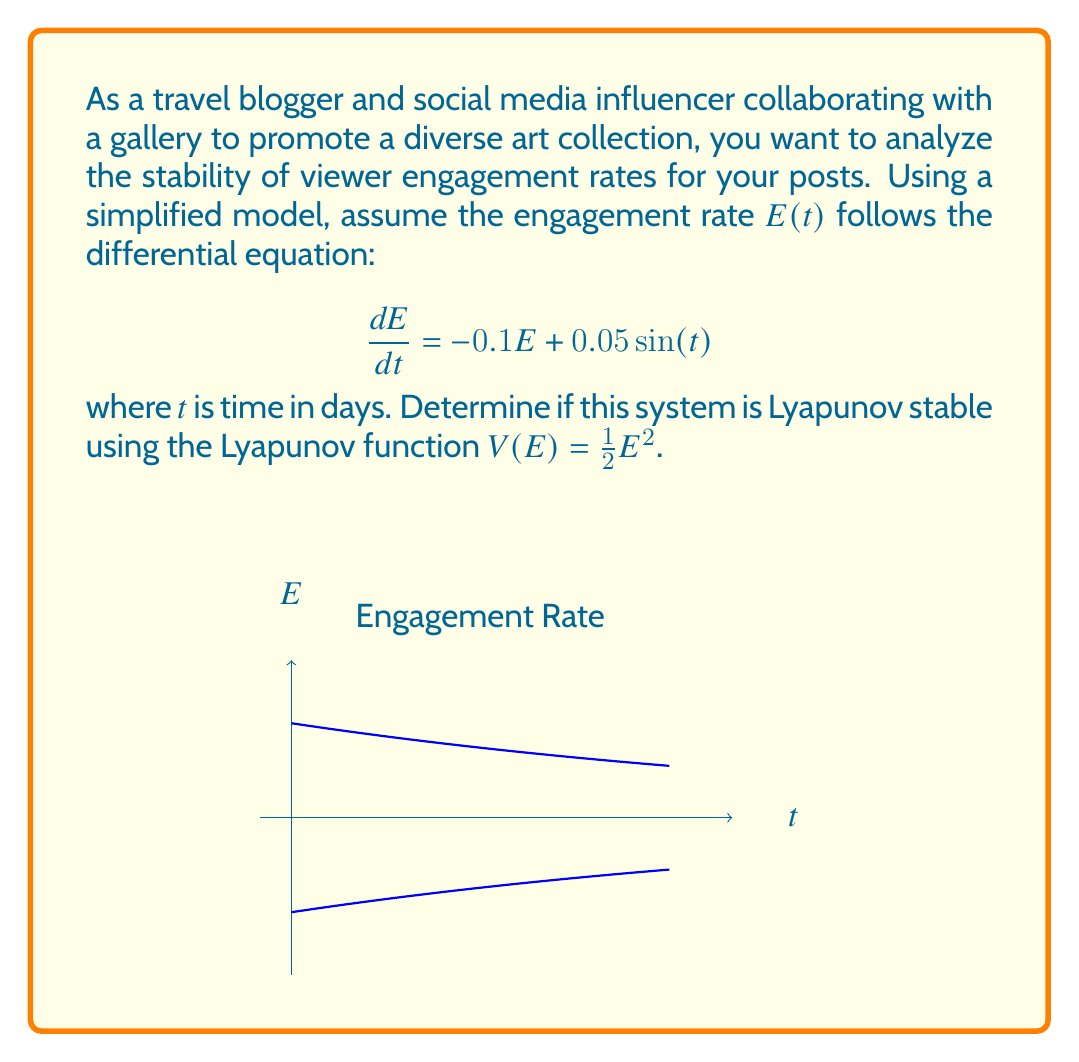Could you help me with this problem? To determine if the system is Lyapunov stable, we need to check if the Lyapunov function $V(E)$ is positive definite and its time derivative $\dot{V}(E)$ is negative semidefinite.

Step 1: Check if $V(E)$ is positive definite
$V(E) = \frac{1}{2}E^2$ is positive definite for all $E \neq 0$ and $V(0) = 0$.

Step 2: Calculate $\dot{V}(E)$
$$\dot{V}(E) = \frac{dV}{dE} \cdot \frac{dE}{dt} = E \cdot \frac{dE}{dt}$$
$$\dot{V}(E) = E \cdot (-0.1E + 0.05\sin(t))$$
$$\dot{V}(E) = -0.1E^2 + 0.05E\sin(t)$$

Step 3: Analyze $\dot{V}(E)$
We need to show that $\dot{V}(E) \leq 0$ for all $E$ and $t$. However, due to the sinusoidal term, $\dot{V}(E)$ can be positive for some values of $E$ and $t$.

For example, when $E > 0$ and $\sin(t) > 0$, or when $E < 0$ and $\sin(t) < 0$, the second term $0.05E\sin(t)$ can make $\dot{V}(E)$ positive if its magnitude is greater than $0.1E^2$.

Step 4: Conclusion
Since we cannot guarantee that $\dot{V}(E) \leq 0$ for all $E$ and $t$, we cannot conclude that the system is Lyapunov stable using this Lyapunov function.

However, it's worth noting that the system is bounded and oscillates around zero due to the negative feedback term $-0.1E$ and the bounded input $0.05\sin(t)$. This suggests that the system might be stable in a broader sense, such as input-to-state stability or ultimate boundedness, but not Lyapunov stable in the strict sense.
Answer: Not Lyapunov stable with the given function. 